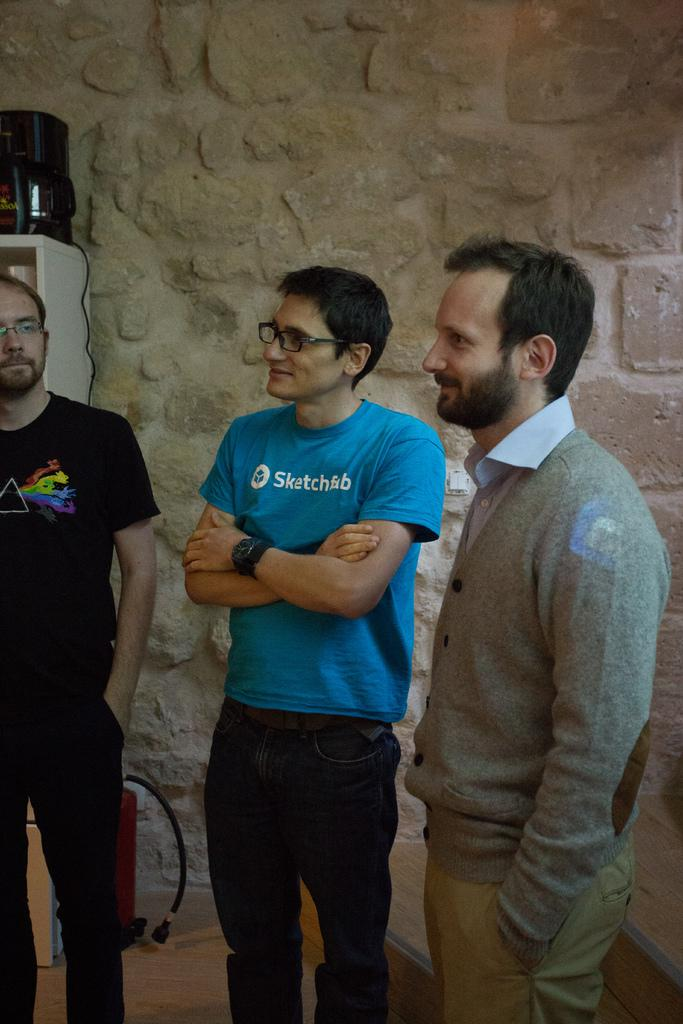How many men are present in the image? There are three men standing in the image. Where are the men standing? The men are standing on the floor. What can be seen in the background of the image? There is an electronic device on a cupboard, a fire extinguisher on the floor, steps, and a wall visible in the background. What type of drink is being served during the war in the image? There is no war or drink present in the image. 